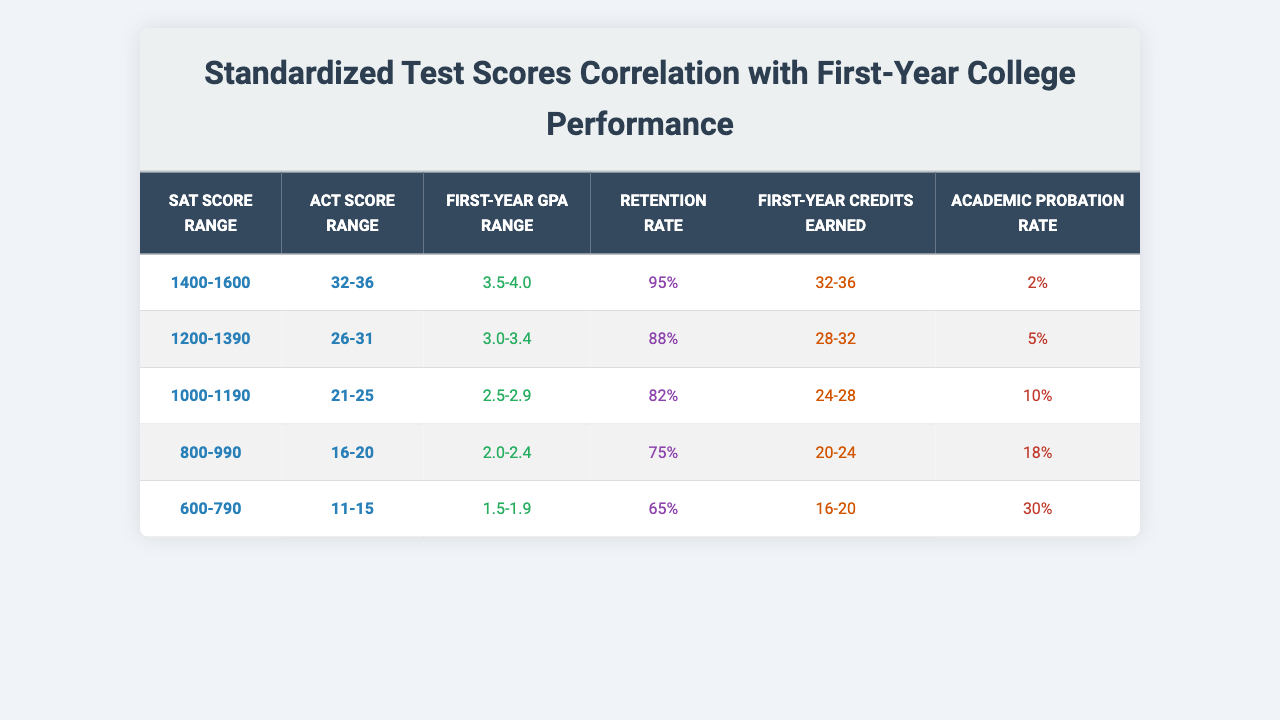What is the retention rate for students with an SAT score between 1400 and 1600? From the table, the retention rate for the SAT score range of 1400-1600 is listed as 95%.
Answer: 95% What is the academic probation rate for students who scored between 800 and 990 on the SAT? The table indicates that the academic probation rate for the SAT score range of 800-990 is 18%.
Answer: 18% How many first-year credits do students typically earn if they score between 1200 and 1390 on the SAT? According to the table, the first-year credits earned by students in the SAT score range of 1200-1390 is between 28 and 32 credits.
Answer: 28-32 Is it true that students who scored between 600 and 790 on the SAT have a higher probation rate than those who scored between 1000 and 1190? True, the probation rate for the SAT score range of 600-790 is 30%, which is higher than the 10% probation rate for those who scored between 1000 and 1190.
Answer: True What is the difference in retention rates between students with an SAT score of 1400-1600 and those with a score of 1000-1190? The retention rate for 1400-1600 is 95%, while for 1000-1190 it is 82%. The difference is 95% - 82% = 13%.
Answer: 13% What are the average first-year GPAs for students in the SAT score range of 1000-1190? The table shows that the first-year GPA range for students who scored between 1000 and 1190 is from 2.5 to 2.9. The average GPA can be calculated as (2.5 + 2.9)/2 = 2.7.
Answer: 2.7 How does the first-year GPA of students with ACT scores between 26 and 31 compare to those with ACT scores of 32-36? The first-year GPA range for ACT scores 26-31 is 3.0-3.4, while for 32-36 it is 3.5-4.0. The GPA for the higher ACT score range is higher.
Answer: Higher What is the average retention rate of all students based on the provided score ranges? The retention rates are 95%, 88%, 82%, 75%, and 65%. The average retention rate is (95 + 88 + 82 + 75 + 65) / 5 = 81%.
Answer: 81% For students scoring between 600 and 790 on the SAT, what is the range of first-year credits earned? The table states that students in the 600-790 SAT range earn from 16 to 20 first-year credits.
Answer: 16-20 How many students scored at least 1400 on the SAT in relation to their GPA and retention rate? Students scoring 1400-1600 have a GPA range of 3.5-4.0 and a retention rate of 95%. Both metrics are high for this group.
Answer: High GPA and retention 